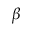<formula> <loc_0><loc_0><loc_500><loc_500>{ \beta }</formula> 